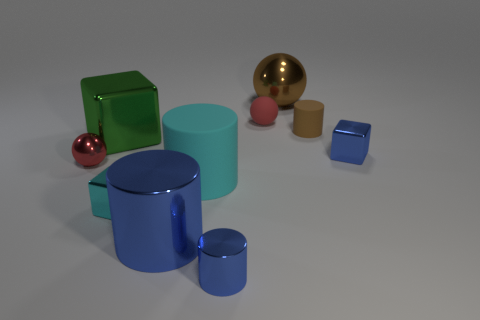Subtract all tiny metal cubes. How many cubes are left? 1 Subtract 1 spheres. How many spheres are left? 2 Subtract all blue cylinders. How many red spheres are left? 2 Subtract all cyan cylinders. How many cylinders are left? 3 Subtract all spheres. How many objects are left? 7 Subtract all cyan shiny cylinders. Subtract all cyan metal blocks. How many objects are left? 9 Add 6 tiny blue blocks. How many tiny blue blocks are left? 7 Add 1 small red matte spheres. How many small red matte spheres exist? 2 Subtract 1 cyan cylinders. How many objects are left? 9 Subtract all purple blocks. Subtract all blue spheres. How many blocks are left? 3 